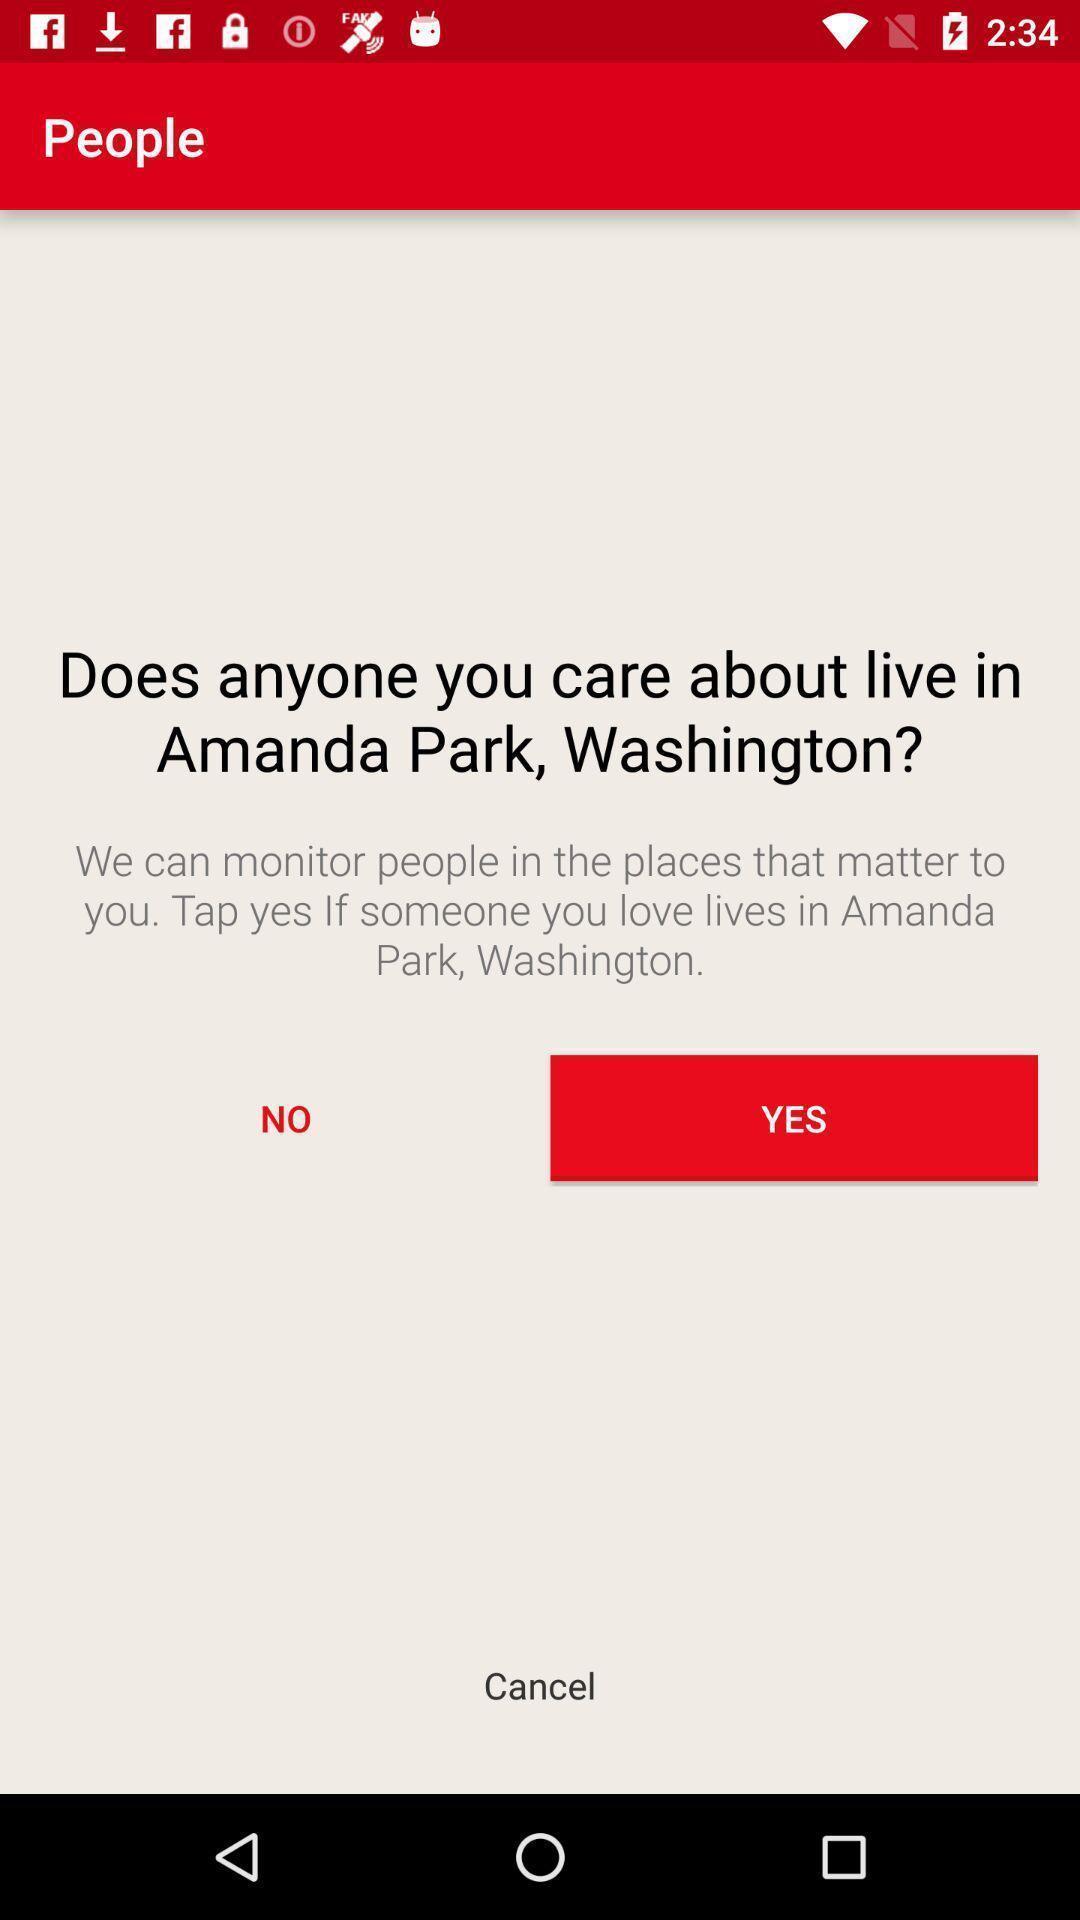Tell me what you see in this picture. Page showing option like yes or no. 